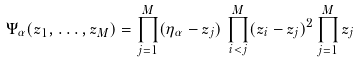Convert formula to latex. <formula><loc_0><loc_0><loc_500><loc_500>\Psi _ { \alpha } ( z _ { 1 } , \dots , z _ { M } ) = \prod _ { j = 1 } ^ { M } ( \eta _ { \alpha } - z _ { j } ) \, \prod _ { i < j } ^ { M } ( z _ { i } - z _ { j } ) ^ { 2 } \prod _ { j = 1 } ^ { M } z _ { j }</formula> 